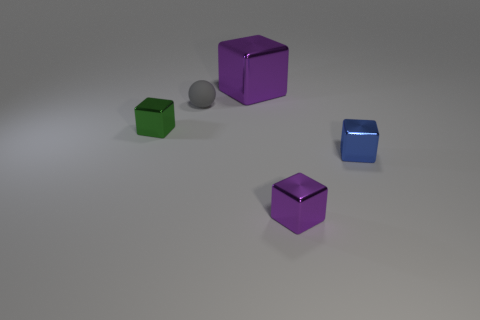Subtract all blue metal cubes. How many cubes are left? 3 Subtract all green blocks. How many blocks are left? 3 Subtract all cubes. How many objects are left? 1 Subtract all yellow cylinders. How many purple cubes are left? 2 Add 5 brown matte blocks. How many objects exist? 10 Add 2 tiny blue rubber balls. How many tiny blue rubber balls exist? 2 Subtract 0 gray blocks. How many objects are left? 5 Subtract all purple spheres. Subtract all purple blocks. How many spheres are left? 1 Subtract all blue cubes. Subtract all matte things. How many objects are left? 3 Add 3 tiny metal blocks. How many tiny metal blocks are left? 6 